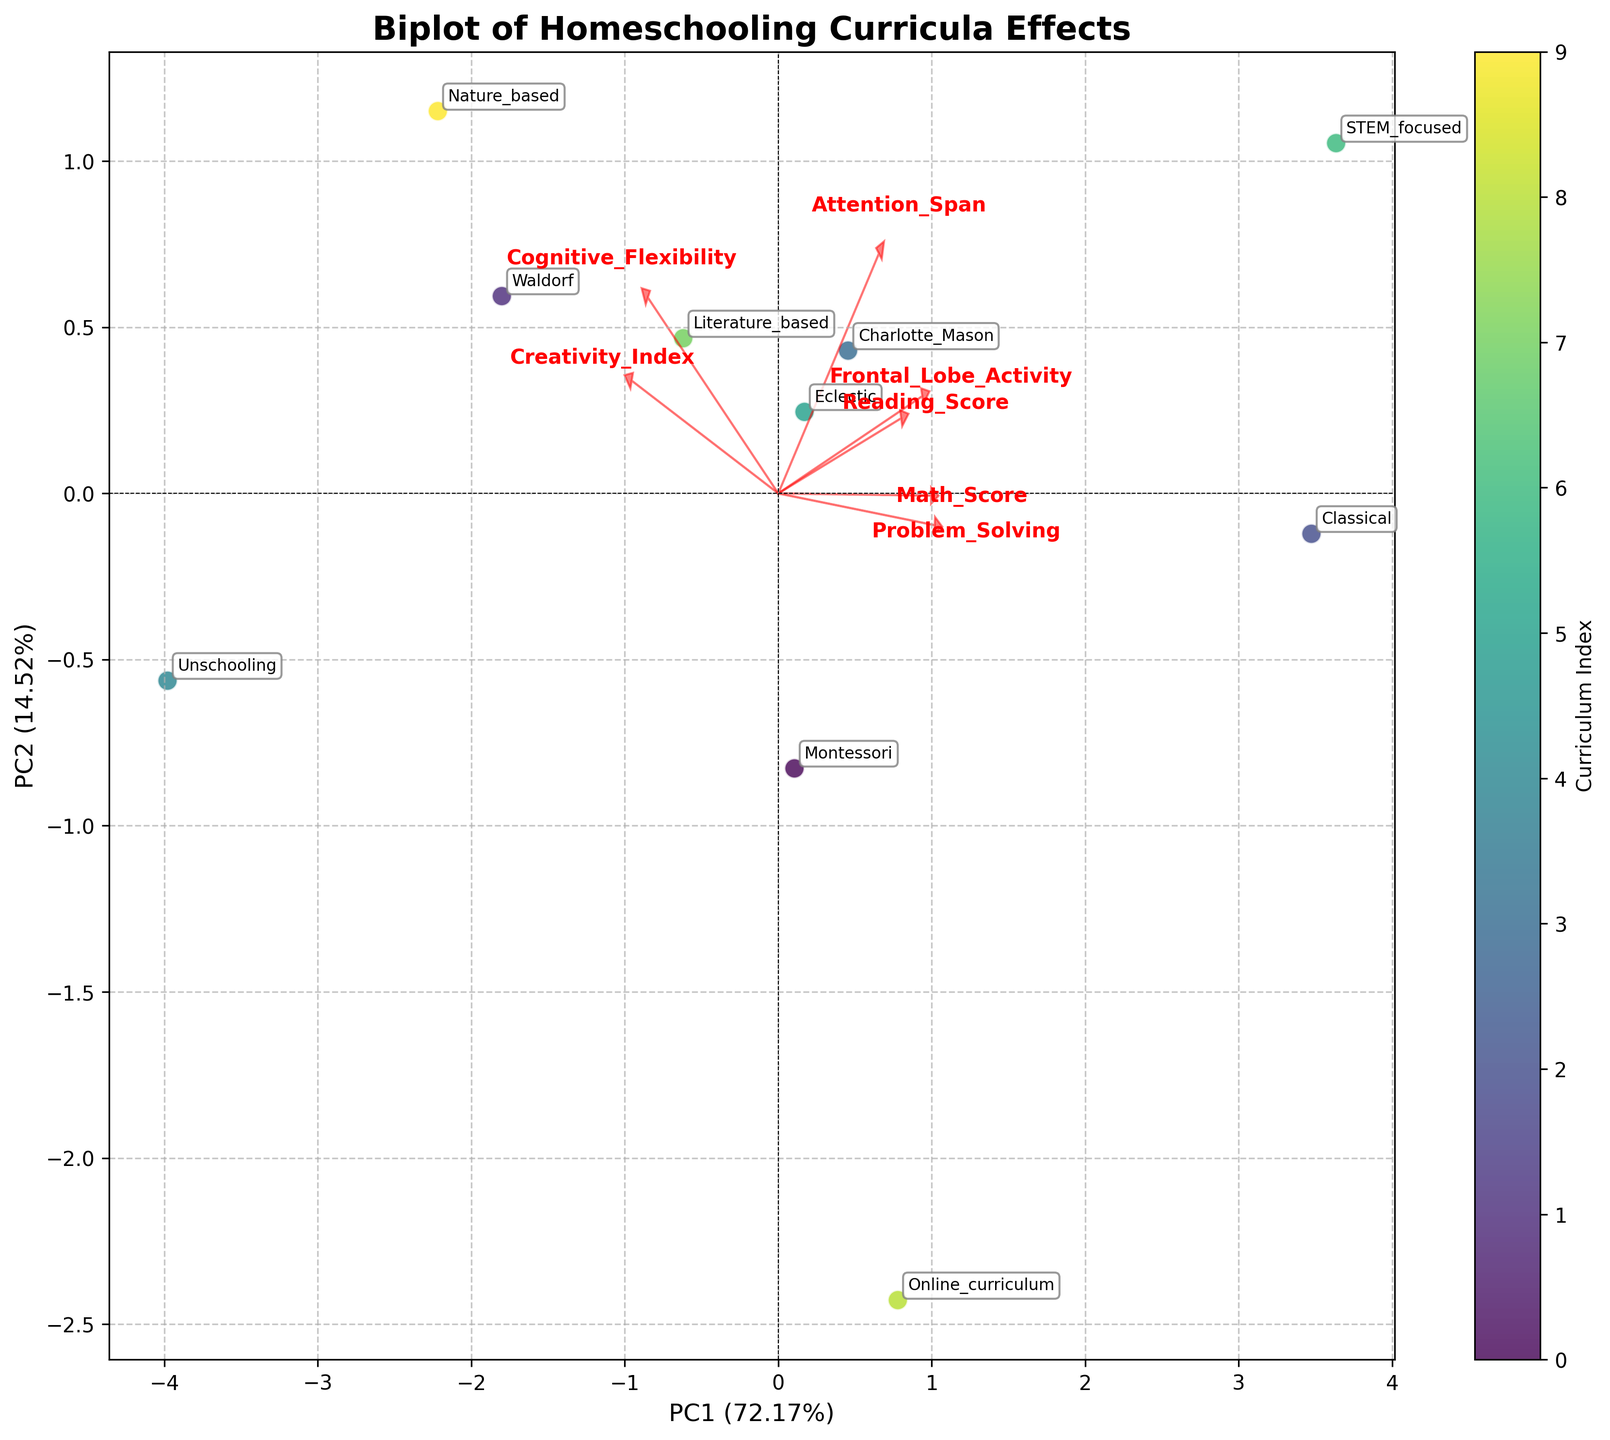What does the arrow pointing to "Frontal_Lobe_Activity" represent? The arrow represents the loading of the variable "Frontal_Lobe_Activity" on the principal components. It indicates the direction and magnitude of this variable's influence on the principal components shown in the biplot.
Answer: The direction and influence of "Frontal_Lobe_Activity" Which curriculum appears closest to the variable "Problem_Solving" on the biplot? By looking at the position of "Problem_Solving" and the curricula points, the "STEM_focused" curriculum appears closest to the "Problem_Solving" variable, suggesting a strong association.
Answer: STEM_focused What percentage of variance is explained by PC1? PC1 is labeled on the x-axis along with the percentage of variance it explains. According to the plot's x-axis label, PC1 explains 50.30% of the variance.
Answer: 50.30% How are "Creativity_Index" and "Math_Score" oriented relative to each other in the biplot? Observing the directions of the arrows representing "Creativity_Index" and "Math_Score", their arrows are pointing in somewhat different directions. This indicates that "Creativity_Index" and "Math_Score" are not strongly correlated but may have some degree of independence.
Answer: Different directions, indicating some independence Which curriculum is highly associated with high values on both PC1 and PC2 dimensions? By identifying the point that is farthest in the positive directions on both PC1 (x-axis) and PC2 (y-axis), "Classical" appears to be highly associated with high values on both dimensions.
Answer: Classical If you wanted to improve "Attention_Span", which curricula should you consider based on their proximity to this variable? Observing the positions of the curricula points relative to the "Attention_Span" arrow, the "Classical", "Charlotte_Mason", and "Nature_based" curricula are close and might be beneficial for improving "Attention_Span".
Answer: Classical, Charlotte_Mason, and Nature_based Which curriculum scores the lowest in "Reading_Score"? By looking at the biplot and identifying the position of the curricula labels in relation to the other labels, "Unschooling" is positioned the lowest in terms of "Reading_Score".
Answer: Unschooling What can you infer from the direction of the "Math_Score" arrow in the biplot? The "Math_Score" arrow points towards the upper right, suggesting that "Math_Score" is positively correlated with both PC1 and PC2. This indicates that higher math scores are associated with the characteristics represented by those principal components.
Answer: Positive correlation with PC1 and PC2 Which two variables appear to be most strongly correlated based on the biplot? In the biplot, "Creativity_Index" and "Frontal_Lobe_Activity" arrows are pointing in similar directions and are close to each other. This suggests a strong positive correlation between these two variables.
Answer: Creativity_Index and Frontal_Lobe_Activity 